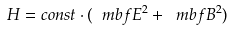<formula> <loc_0><loc_0><loc_500><loc_500>H = c o n s t \cdot ( \ m b f { E } ^ { 2 } + \ m b f { B } ^ { 2 } )</formula> 